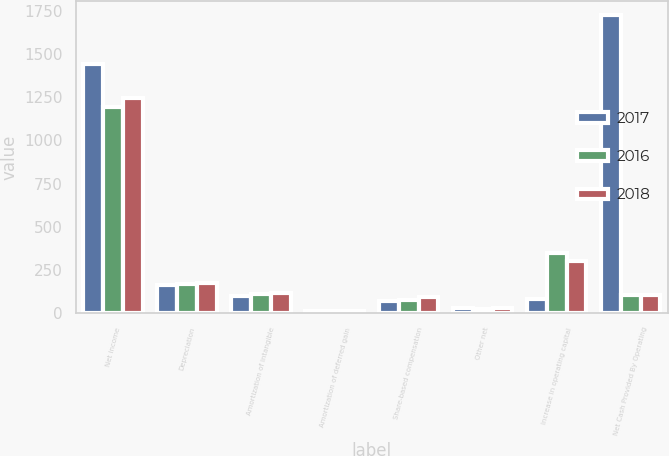Convert chart to OTSL. <chart><loc_0><loc_0><loc_500><loc_500><stacked_bar_chart><ecel><fcel>Net income<fcel>Depreciation<fcel>Amortization of intangible<fcel>Amortization of deferred gain<fcel>Share-based compensation<fcel>Other net<fcel>Increase in operating capital<fcel>Net Cash Provided By Operating<nl><fcel>2017<fcel>1440.5<fcel>161.5<fcel>102.5<fcel>12.9<fcel>70.5<fcel>29.2<fcel>80.5<fcel>1722.3<nl><fcel>2016<fcel>1192.2<fcel>168.3<fcel>113.8<fcel>12.9<fcel>80.2<fcel>27.5<fcel>348.5<fcel>108.15<nl><fcel>2018<fcel>1246.7<fcel>177.7<fcel>115.2<fcel>15.4<fcel>93.4<fcel>32<fcel>302.8<fcel>108.15<nl></chart> 